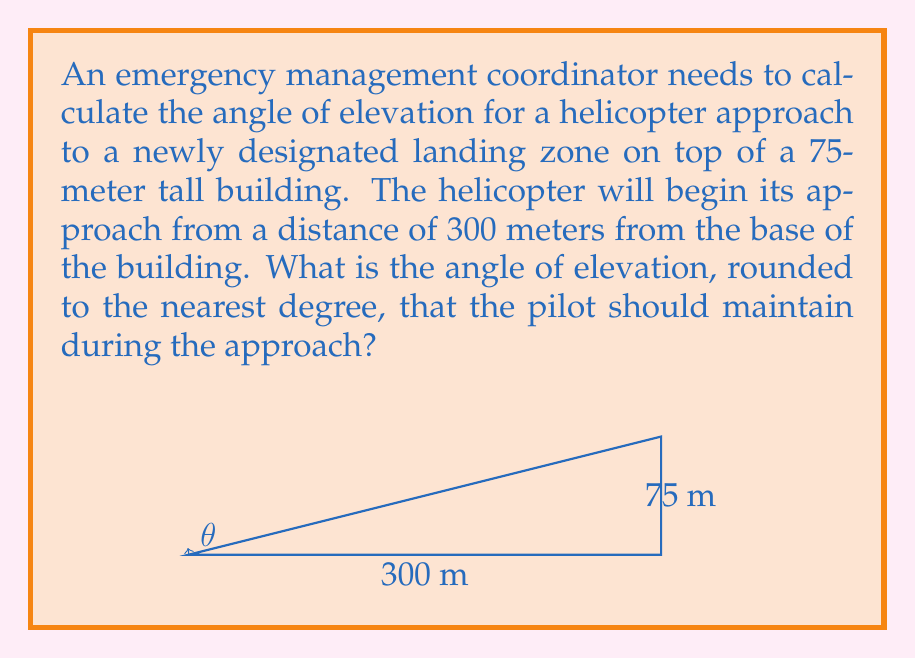Can you solve this math problem? To solve this problem, we need to use the tangent function from trigonometry. The tangent of an angle in a right triangle is the ratio of the opposite side to the adjacent side.

Let's break down the problem:
1. The opposite side is the height of the building: 75 meters
2. The adjacent side is the distance from the base of the building: 300 meters
3. We need to find the angle $\theta$

We can set up the equation:

$$\tan(\theta) = \frac{\text{opposite}}{\text{adjacent}} = \frac{75}{300}$$

To find $\theta$, we need to use the inverse tangent (arctangent) function:

$$\theta = \arctan(\frac{75}{300})$$

Using a calculator or computer:

$$\theta = \arctan(0.25) \approx 14.0362^\circ$$

Rounding to the nearest degree:

$$\theta \approx 14^\circ$$

This means the helicopter pilot should maintain an angle of elevation of approximately 14 degrees during the approach to safely land on top of the building.
Answer: 14° 